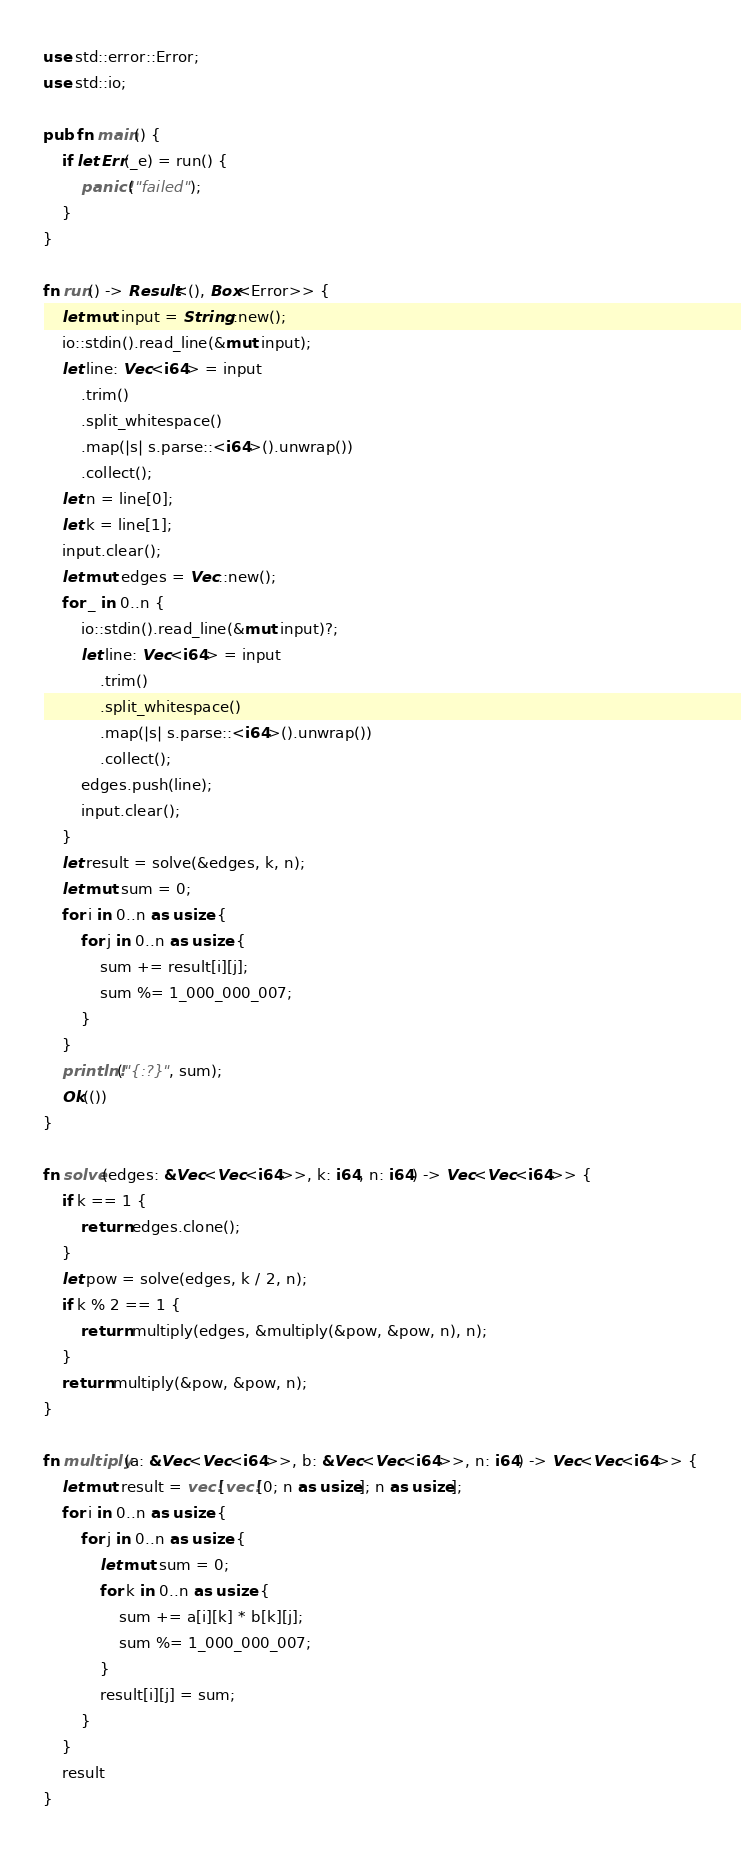Convert code to text. <code><loc_0><loc_0><loc_500><loc_500><_Rust_>use std::error::Error;
use std::io;

pub fn main() {
    if let Err(_e) = run() {
        panic!("failed");
    }
}

fn run() -> Result<(), Box<Error>> {
    let mut input = String::new();
    io::stdin().read_line(&mut input);
    let line: Vec<i64> = input
        .trim()
        .split_whitespace()
        .map(|s| s.parse::<i64>().unwrap())
        .collect();
    let n = line[0];
    let k = line[1];
    input.clear();
    let mut edges = Vec::new();
    for _ in 0..n {
        io::stdin().read_line(&mut input)?;
        let line: Vec<i64> = input
            .trim()
            .split_whitespace()
            .map(|s| s.parse::<i64>().unwrap())
            .collect();
        edges.push(line);
        input.clear();
    }
    let result = solve(&edges, k, n);
    let mut sum = 0;
    for i in 0..n as usize {
        for j in 0..n as usize {
            sum += result[i][j];
            sum %= 1_000_000_007;
        }
    }
    println!("{:?}", sum);
    Ok(())
}

fn solve(edges: &Vec<Vec<i64>>, k: i64, n: i64) -> Vec<Vec<i64>> {
    if k == 1 {
        return edges.clone();
    }
    let pow = solve(edges, k / 2, n);
    if k % 2 == 1 {
        return multiply(edges, &multiply(&pow, &pow, n), n);
    }
    return multiply(&pow, &pow, n);
}

fn multiply(a: &Vec<Vec<i64>>, b: &Vec<Vec<i64>>, n: i64) -> Vec<Vec<i64>> {
    let mut result = vec![vec![0; n as usize]; n as usize];
    for i in 0..n as usize {
        for j in 0..n as usize {
            let mut sum = 0;
            for k in 0..n as usize {
                sum += a[i][k] * b[k][j];
                sum %= 1_000_000_007;
            }
            result[i][j] = sum;
        }
    }
    result
}
</code> 